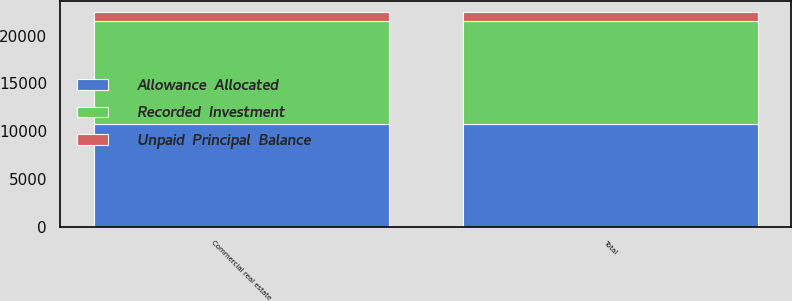<chart> <loc_0><loc_0><loc_500><loc_500><stacked_bar_chart><ecel><fcel>Commercial real estate<fcel>Total<nl><fcel>Recorded  Investment<fcel>10750<fcel>10750<nl><fcel>Allowance  Allocated<fcel>10750<fcel>10750<nl><fcel>Unpaid  Principal  Balance<fcel>1000<fcel>1000<nl></chart> 